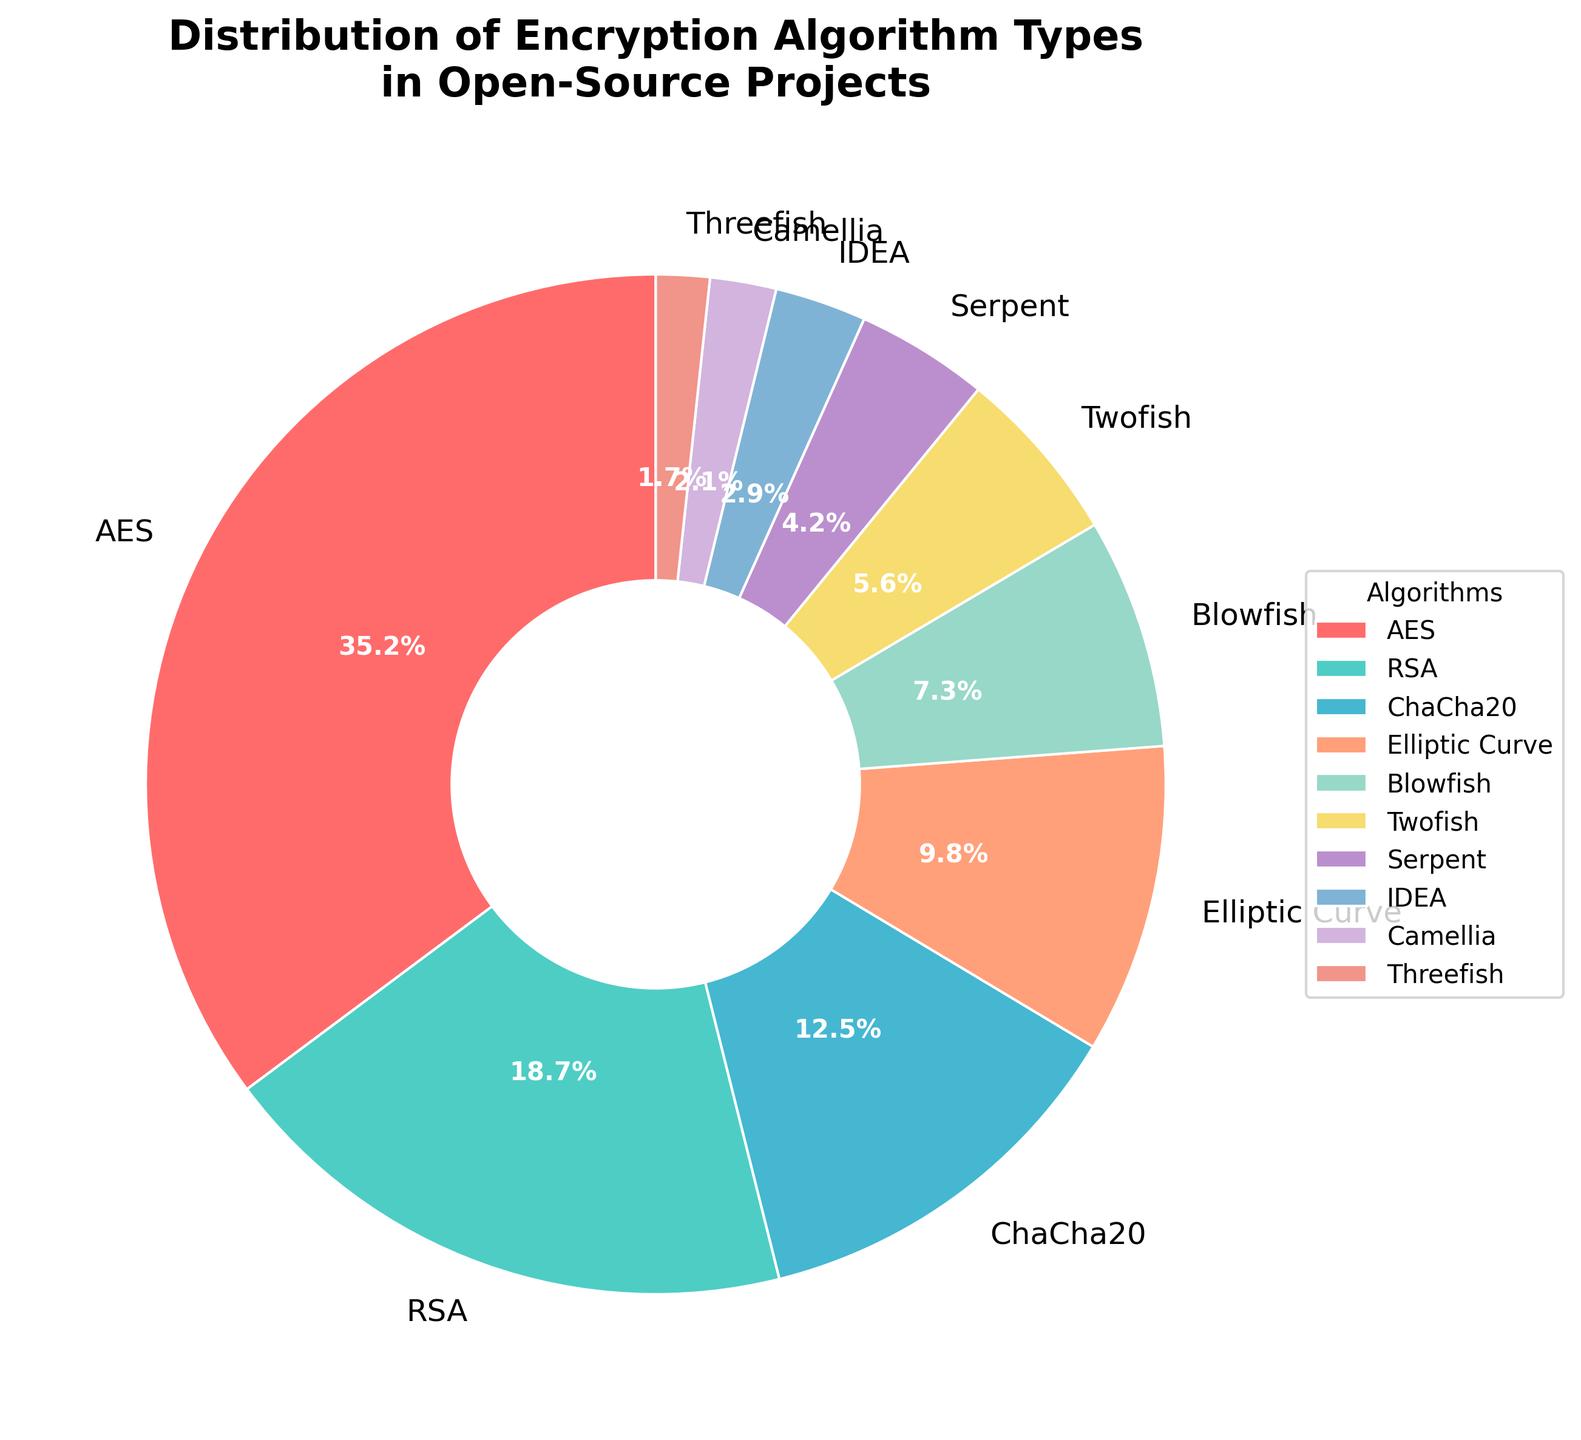What are the three most commonly used encryption algorithms in open-source projects? The three largest slices in the pie chart, by their percentages, represent the most commonly used algorithms. These are AES (35.2%), RSA (18.7%), and ChaCha20 (12.5%).
Answer: AES, RSA, ChaCha20 How much more popular is AES compared to ChaCha20? Subtract the percentage of ChaCha20 from the percentage of AES. AES has 35.2% and ChaCha20 has 12.5%, so the difference is 35.2% - 12.5% = 22.7%.
Answer: 22.7% What is the combined percentage of Elliptic Curve, Blowfish, and Twofish algorithms? Sum the percentages of Elliptic Curve (9.8%), Blowfish (7.3%), and Twofish (5.6%). 9.8% + 7.3% + 5.6% = 22.7%.
Answer: 22.7% Which algorithm is represented by the smallest slice, and what is its percentage? The smallest slice represents the algorithm with the lowest percentage. According to the data, Threefish has the smallest percentage at 1.7%.
Answer: Threefish, 1.7% Is the combined usage percentage of IDEA and Camellia higher than that of Serpent? Calculate the combined percentage of IDEA (2.9%) and Camellia (2.1%), which equals 5.0%. Compare this to Serpent’s percentage, which is 4.2%. Since 5.0% > 4.2%, the combined usage of IDEA and Camellia is higher than Serpent’s.
Answer: Yes Do AES and RSA jointly cover more than 50% of the usage in open-source projects? Sum the percentages of AES (35.2%) and RSA (18.7%). Their combined percentage is 35.2% + 18.7% = 53.9%, which is more than 50%.
Answer: Yes, 53.9% Which algorithm’s slice is colored red? The pie chart uses a predefined color scheme where the colors are assigned in sequence based on the data. Assuming the sequence listed in the provided code, the first color ('#FF6B6B') corresponds to the first algorithm in the list, which is AES. Therefore, AES is colored red.
Answer: AES 